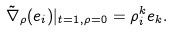<formula> <loc_0><loc_0><loc_500><loc_500>\tilde { \nabla } _ { \rho } ( e _ { i } ) | _ { t = 1 , \rho = 0 } = \rho _ { i } ^ { k } e _ { k } .</formula> 